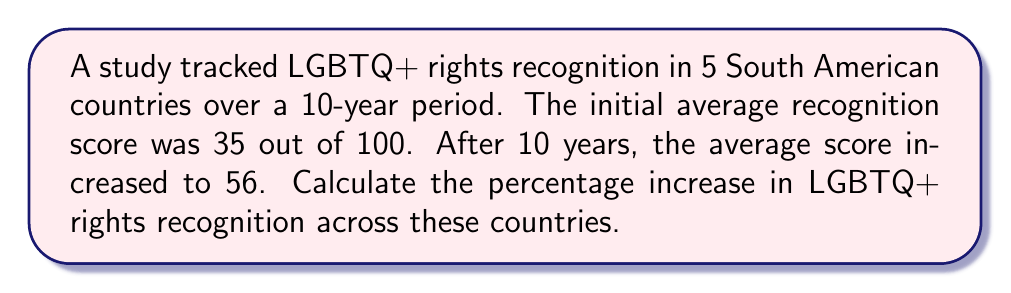Could you help me with this problem? To calculate the percentage increase, we need to follow these steps:

1. Calculate the absolute increase:
   $\text{Increase} = \text{Final score} - \text{Initial score}$
   $\text{Increase} = 56 - 35 = 21$

2. Calculate the percentage increase using the formula:
   $$\text{Percentage Increase} = \frac{\text{Increase}}{\text{Initial score}} \times 100\%$$

3. Substitute the values:
   $$\text{Percentage Increase} = \frac{21}{35} \times 100\%$$

4. Perform the division:
   $$\text{Percentage Increase} = 0.6 \times 100\%$$

5. Convert to percentage:
   $$\text{Percentage Increase} = 60\%$$

Therefore, the percentage increase in LGBTQ+ rights recognition across these South American countries over the 10-year period is 60%.
Answer: 60% 